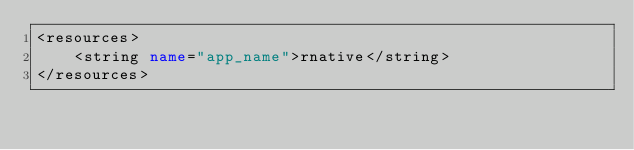Convert code to text. <code><loc_0><loc_0><loc_500><loc_500><_XML_><resources>
    <string name="app_name">rnative</string>
</resources>
</code> 